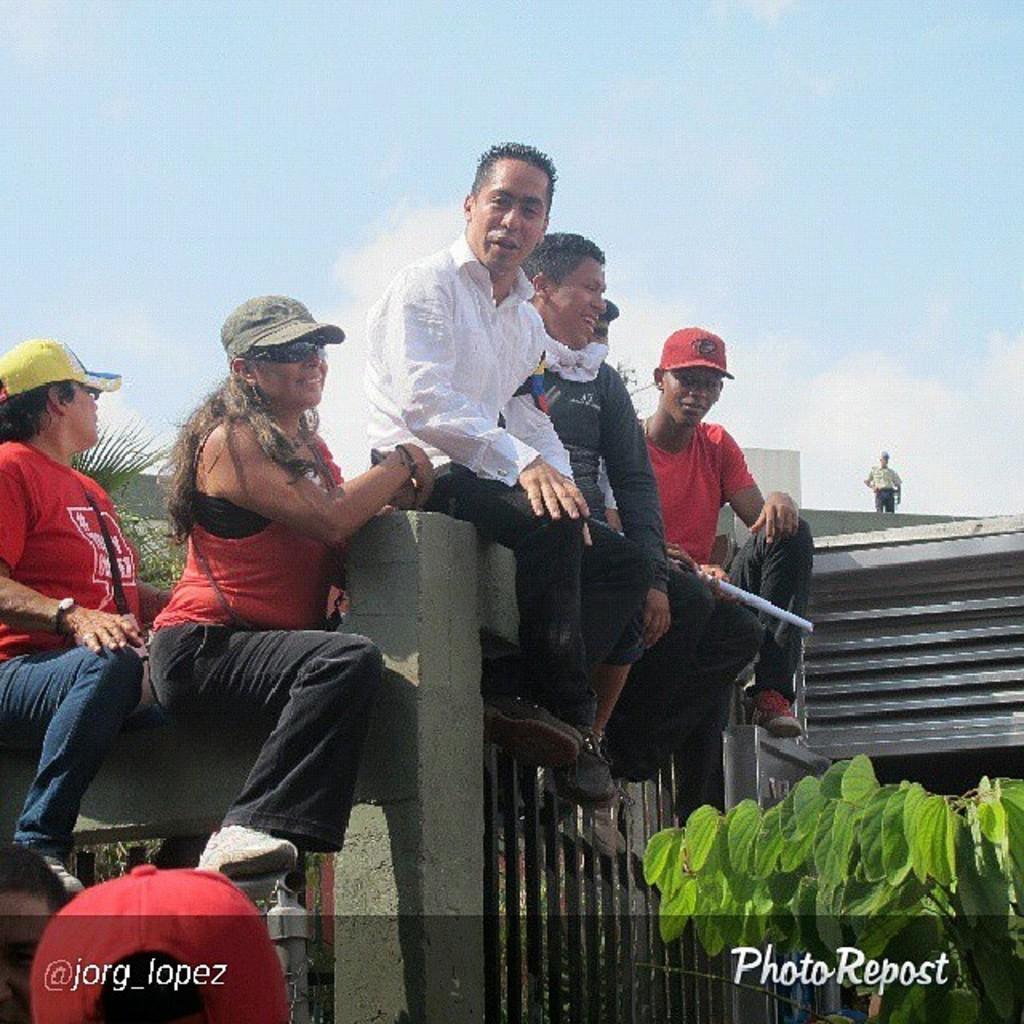What are the people in the image doing? The people in the image are sitting above the wall. Can you describe the wall in the image? The wall has iron rods fixed below the cement part. What can be seen on the right side of the image? There is a plant on the right side of the image. What type of glove is the person wearing on their left hand in the image? There is no glove visible on anyone's hand in the image. How many brothers are sitting on the wall in the image? The image does not provide information about the number of brothers or any familial relationships among the people sitting on the wall. 